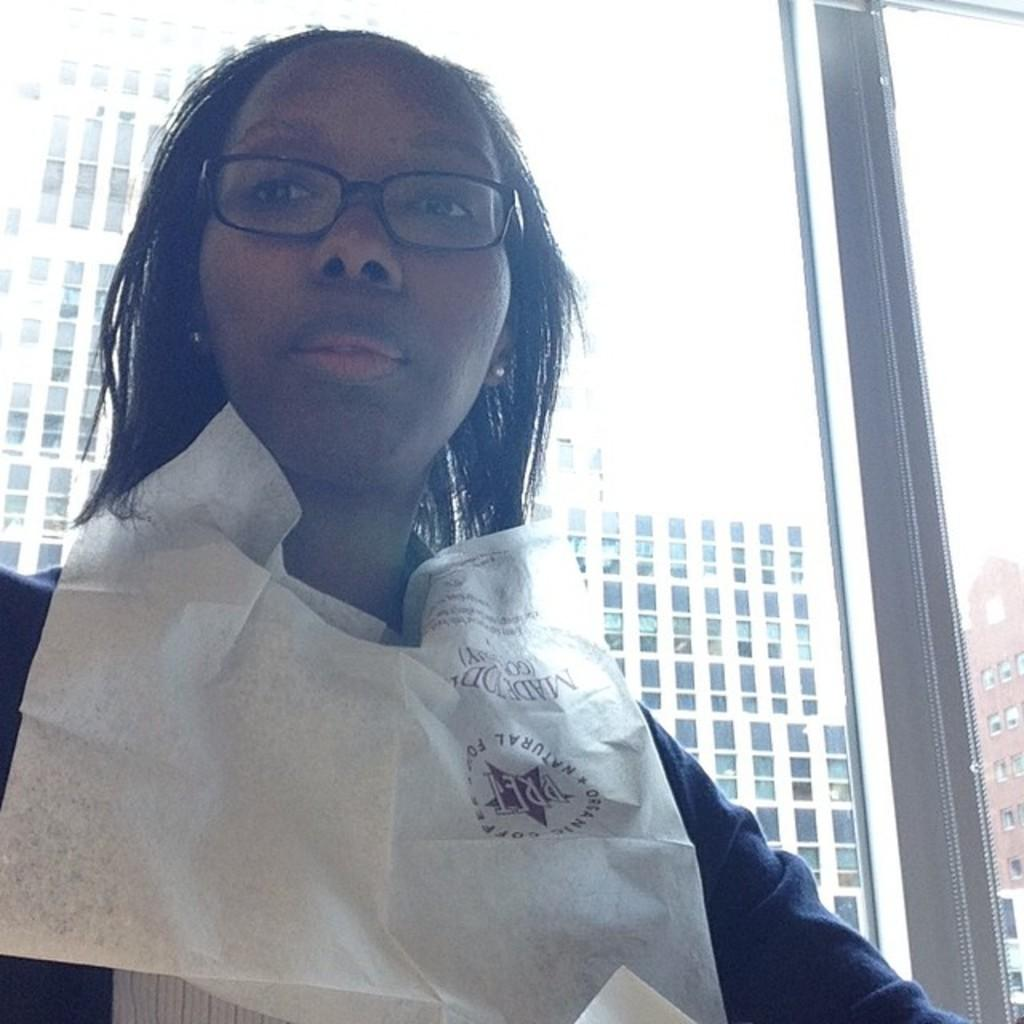Who is the main subject in the image? There is a woman in the center of the image. What can be seen in the background of the image? There is a window, buildings, and the sky visible in the background of the image. What is the name of the woman's dad in the image? There is no information about the woman's dad or any names in the image. 